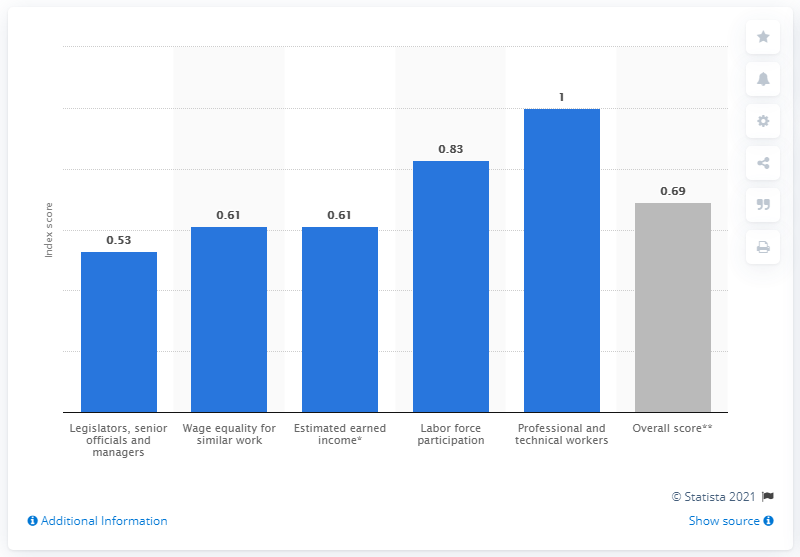Mention a couple of crucial points in this snapshot. In 2021, Uruguay's gender gap index score was 0.69, indicating that the country has made progress in closing the gender gap, but still has room for improvement. 